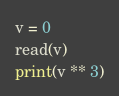<code> <loc_0><loc_0><loc_500><loc_500><_Python_>v = 0
read(v)
print(v ** 3)</code> 